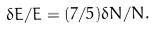Convert formula to latex. <formula><loc_0><loc_0><loc_500><loc_500>\delta E / E = ( 7 / 5 ) \delta N / N .</formula> 